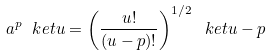Convert formula to latex. <formula><loc_0><loc_0><loc_500><loc_500>a ^ { p } \ k e t { u } = \left ( \frac { u ! } { ( u - p ) ! } \right ) ^ { 1 / 2 } \ k e t { u - p }</formula> 